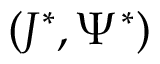<formula> <loc_0><loc_0><loc_500><loc_500>( J ^ { * } , \Psi ^ { * } )</formula> 